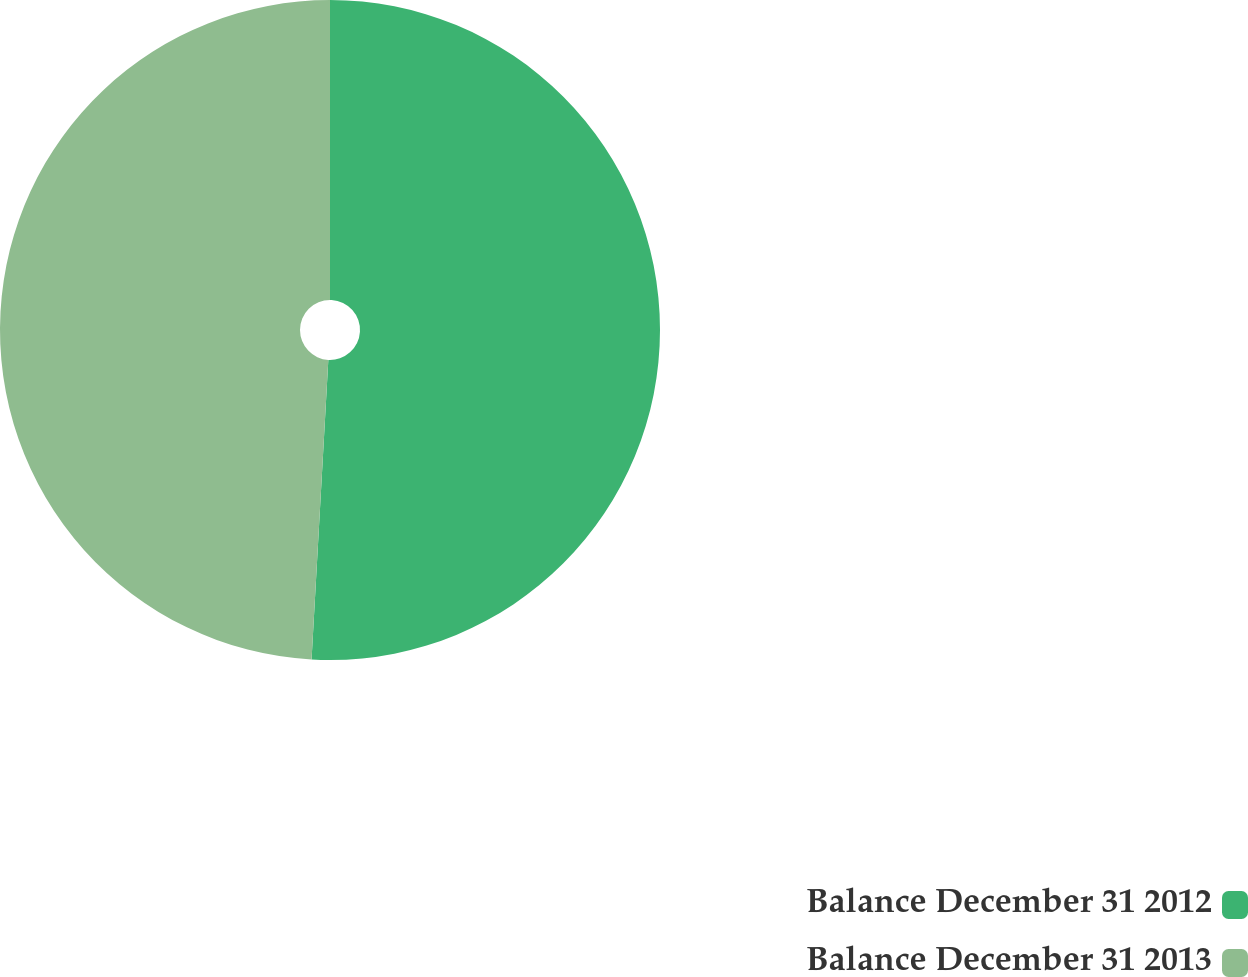<chart> <loc_0><loc_0><loc_500><loc_500><pie_chart><fcel>Balance December 31 2012<fcel>Balance December 31 2013<nl><fcel>50.89%<fcel>49.11%<nl></chart> 